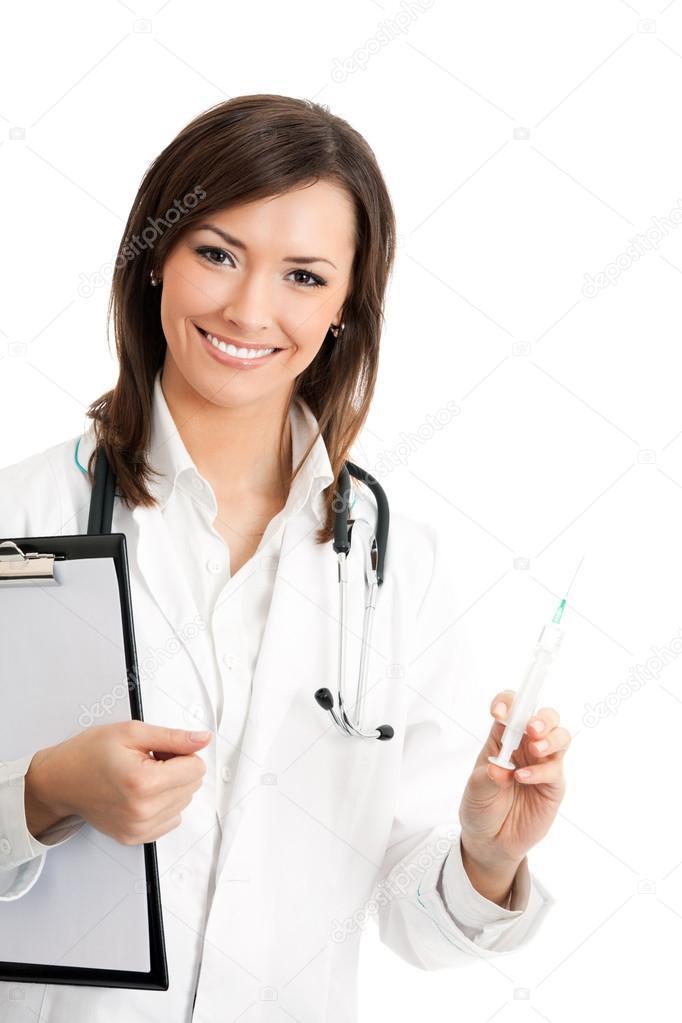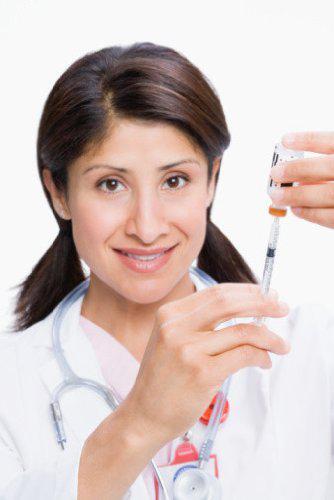The first image is the image on the left, the second image is the image on the right. Given the left and right images, does the statement "There are two women holding needles." hold true? Answer yes or no. Yes. The first image is the image on the left, the second image is the image on the right. Analyze the images presented: Is the assertion "Two women are holding syringes." valid? Answer yes or no. Yes. 